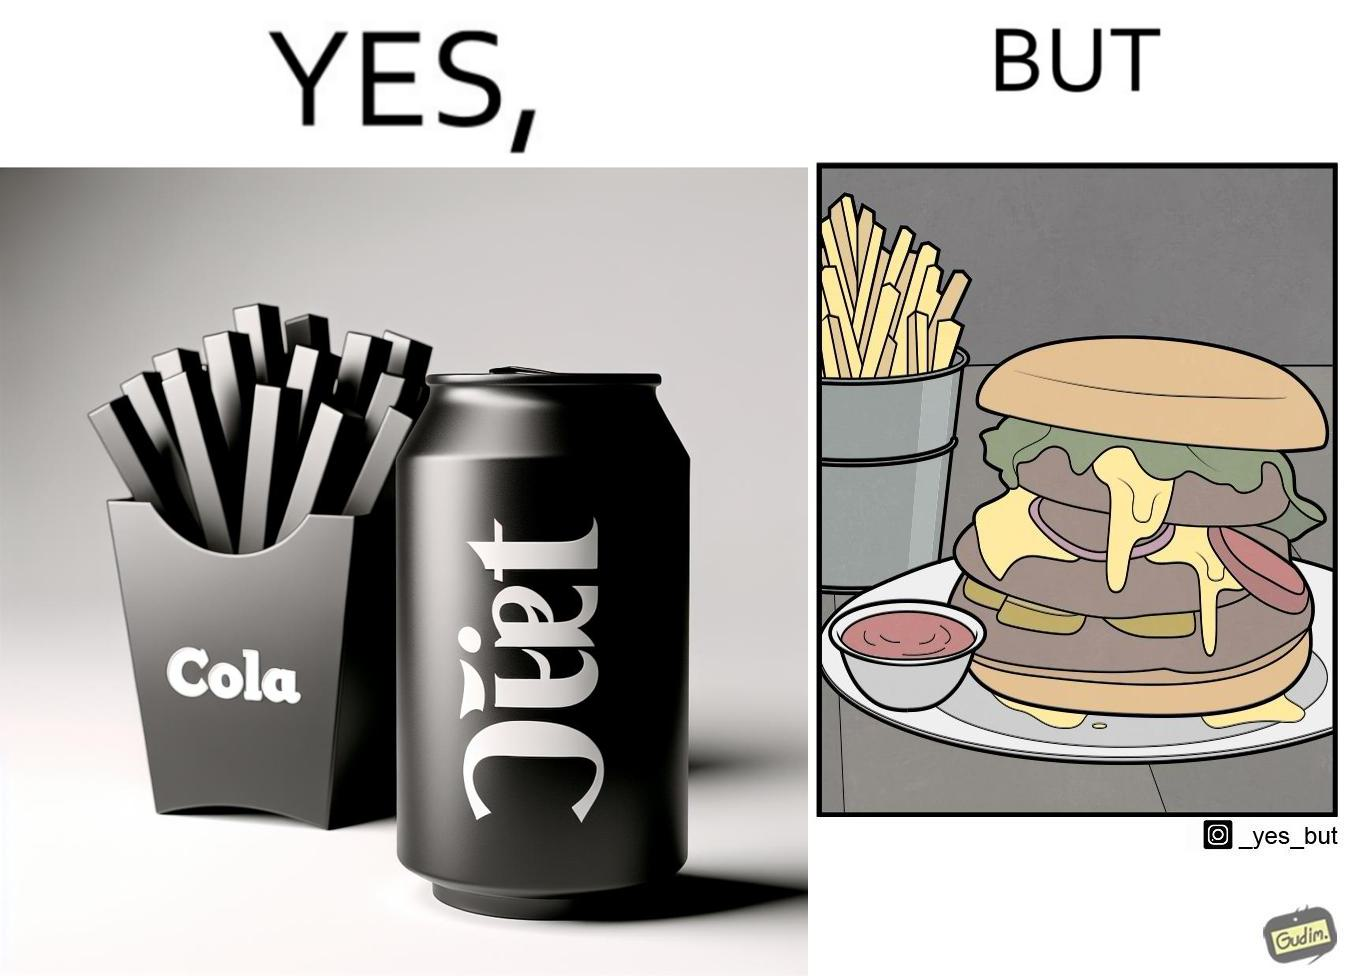What is shown in this image? The image is ironic, because on one hand the person is consuming diet cola suggesting low on sugar as per label meaning the person is health-conscious but on the other hand the same one is having huge size burger with french fries which suggests the person to be health-ignorant 